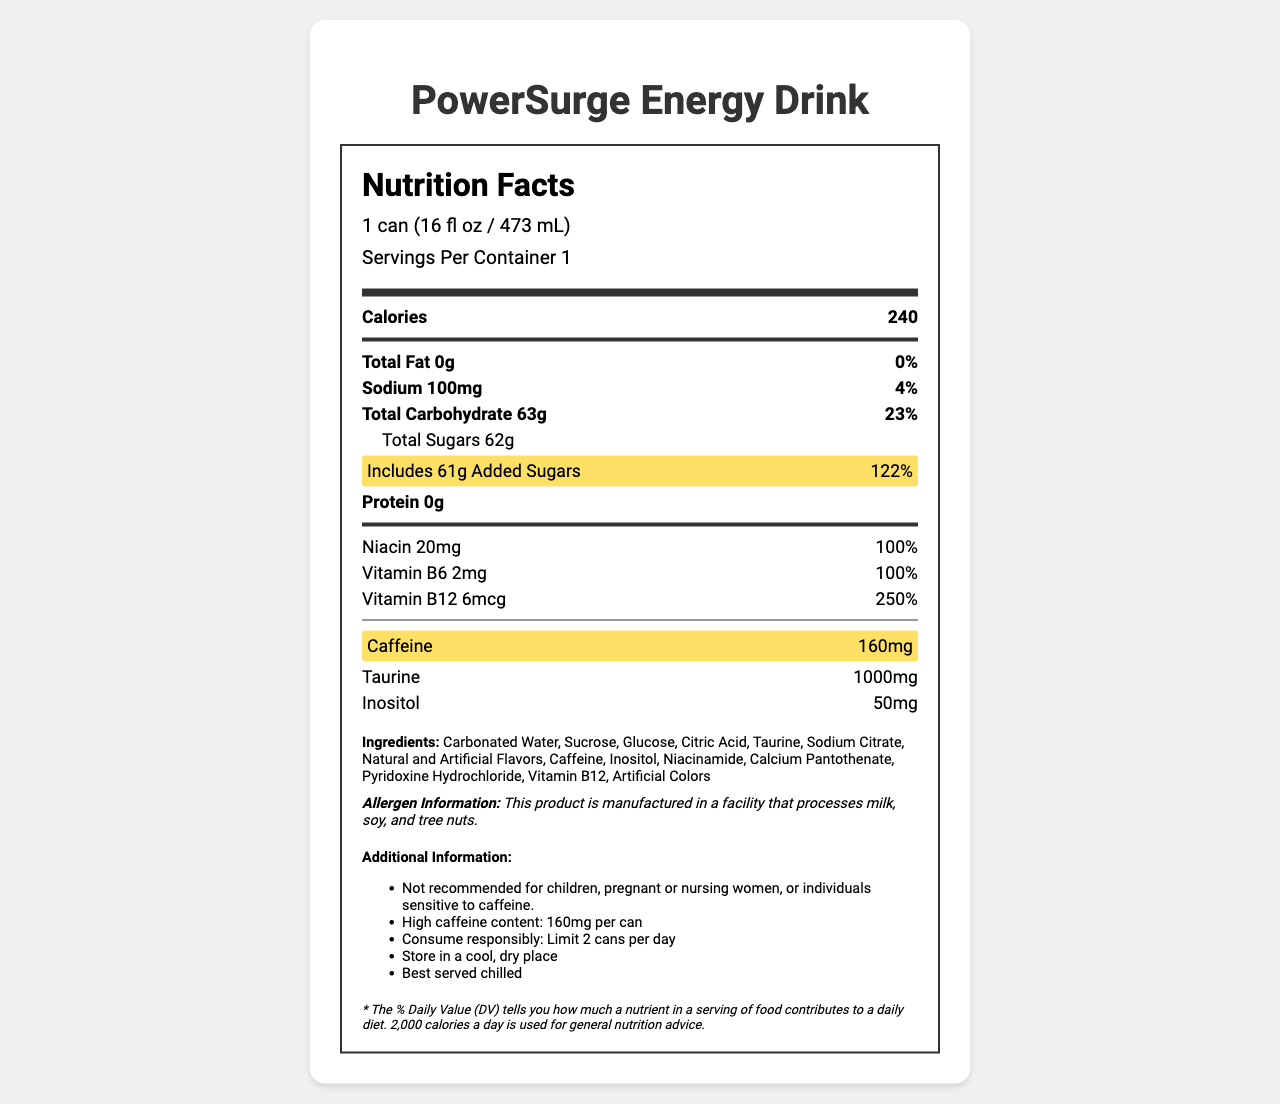What is the serving size for PowerSurge Energy Drink? The serving size is mentioned in the label header section under the "Nutrition Facts" title.
Answer: 1 can (16 fl oz / 473 mL) How many calories are in one serving of PowerSurge Energy Drink? The number of calories per serving is listed in the main nutrient section under "Calories."
Answer: 240 What is the amount of caffeine in one can of PowerSurge Energy Drink? The caffeine content is specified in the highlighted nutrient row.
Answer: 160mg What percentage of the daily value for added sugars does one can of PowerSurge Energy Drink contain? The percentage daily value for added sugars is highlighted in the sub-nutrient section.
Answer: 122% How much sodium is in one serving of PowerSurge Energy Drink? The sodium content is listed in the main nutrient section under "Sodium."
Answer: 100mg Which B vitamins are included in PowerSurge Energy Drink? The B vitamins are listed with their respective amounts and percentage daily values in the nutrient rows.
Answer: Niacin, Vitamin B6, Vitamin B12 Which of the following statements about PowerSurge Energy Drink is true? 
A. It contains 1g of sugar.
B. It contains no caffeine.
C. It contains 1000mg of taurine.
D. It contains 50mg of inositol. The correct answer is C. The document mentions that PowerSurge Energy Drink contains 1000mg of taurine under the nutrient section.
Answer: C What is the main ingredient in PowerSurge Energy Drink? 
A. Taurine
B. Carbonated Water
C. Caffeine
D. Inositol The correct answer is B. Carbonated Water is listed as the first ingredient, indicating it is the main ingredient.
Answer: B Is this product recommended for children? The additional information section states that it is not recommended for children, pregnant or nursing women, or individuals sensitive to caffeine.
Answer: No Describe the main idea of the Nutrition Facts Label for PowerSurge Energy Drink. This label outlines the energy drink's nutritional breakdown and health-related advisories, emphasizing its high caffeine and added sugar content and recommending responsible consumption.
Answer: The Nutrition Facts Label provides detailed information about the nutritional content of PowerSurge Energy Drink, including serving size, calories, and amounts of various nutrients such as fat, sodium, carbohydrates, sugars, protein, and vitamins. Key highlights include high caffeine content and added sugars, along with a list of ingredients and allergen information. What is the sodium content in 2 cans of PowerSurge Energy Drink? The document only provides the sodium content per serving, which is one can. To find the sodium content in 2 cans, you would need to do additional calculations not provided visually in the document.
Answer: Not enough information 